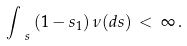Convert formula to latex. <formula><loc_0><loc_0><loc_500><loc_500>\int _ { \ s } \left ( 1 - s _ { 1 } \right ) \nu ( d { s } ) \, < \, \infty \, .</formula> 